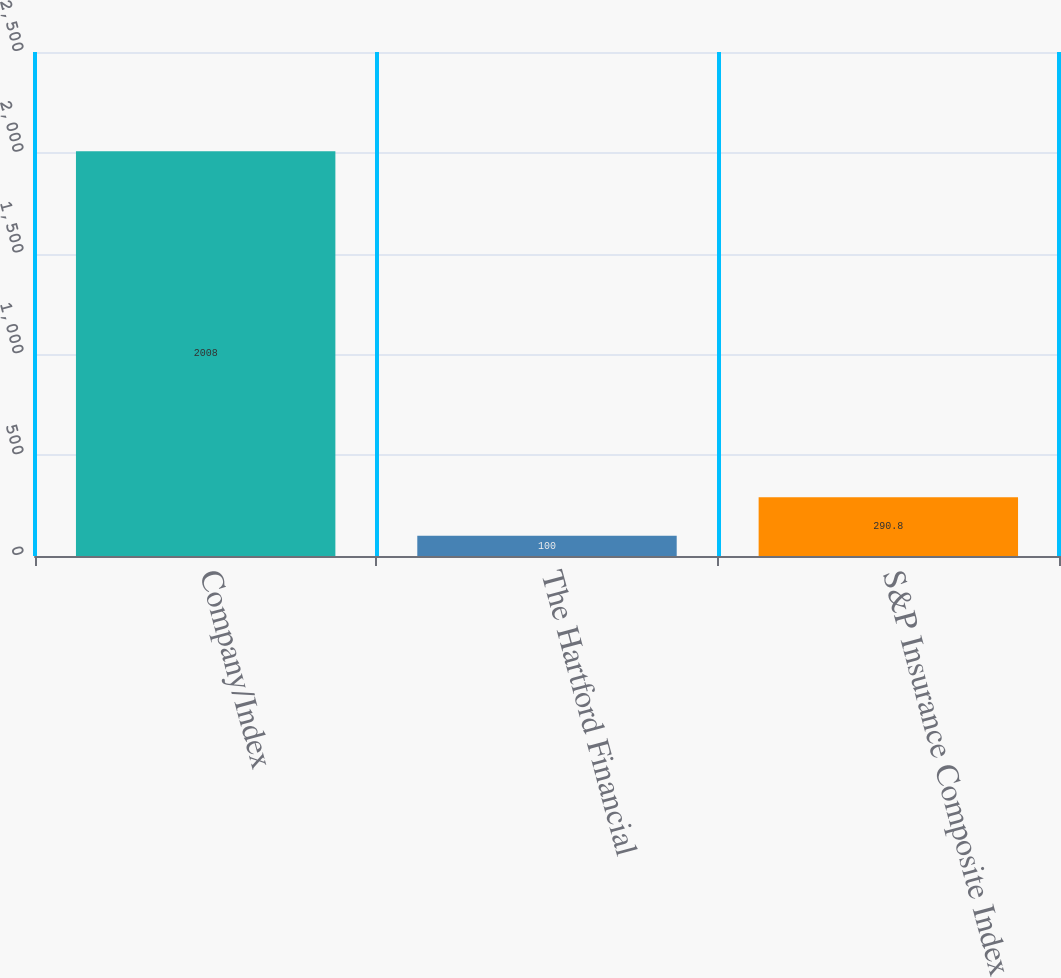<chart> <loc_0><loc_0><loc_500><loc_500><bar_chart><fcel>Company/Index<fcel>The Hartford Financial<fcel>S&P Insurance Composite Index<nl><fcel>2008<fcel>100<fcel>290.8<nl></chart> 